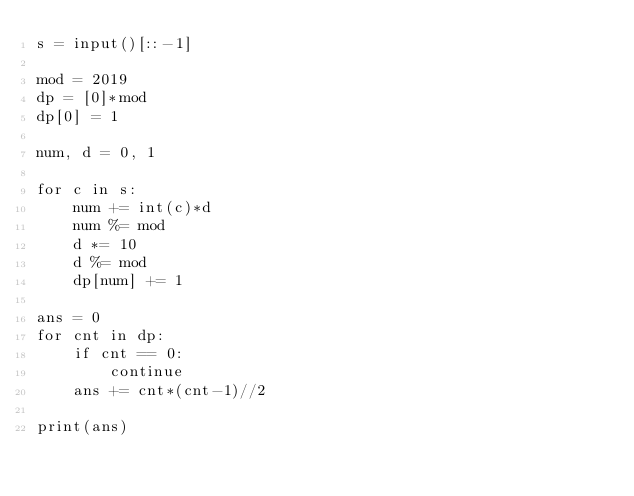<code> <loc_0><loc_0><loc_500><loc_500><_Python_>s = input()[::-1]

mod = 2019
dp = [0]*mod
dp[0] = 1

num, d = 0, 1

for c in s:
    num += int(c)*d
    num %= mod
    d *= 10
    d %= mod
    dp[num] += 1

ans = 0
for cnt in dp:
    if cnt == 0:
        continue
    ans += cnt*(cnt-1)//2

print(ans)</code> 